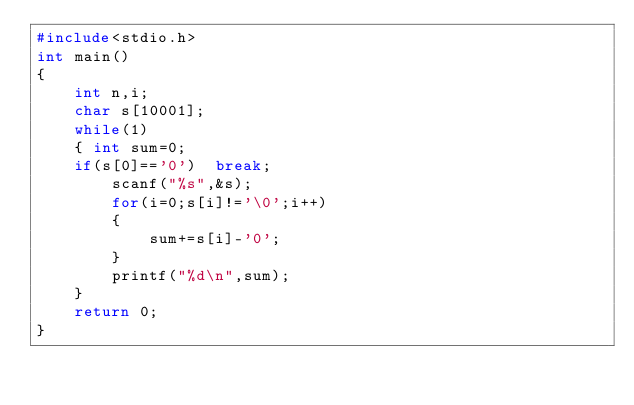<code> <loc_0><loc_0><loc_500><loc_500><_C_>#include<stdio.h>
int main()
{
    int n,i;
    char s[10001];
    while(1)
    { int sum=0;
    if(s[0]=='0')  break;
        scanf("%s",&s);
        for(i=0;s[i]!='\0';i++)
        {
            sum+=s[i]-'0';
        }
        printf("%d\n",sum);
    }
    return 0;
}

</code> 